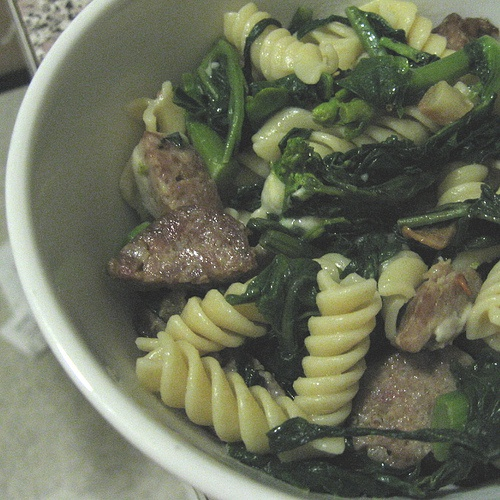Describe the objects in this image and their specific colors. I can see bowl in gray, black, darkgreen, and olive tones, broccoli in darkgreen and black tones, and broccoli in darkgreen and black tones in this image. 